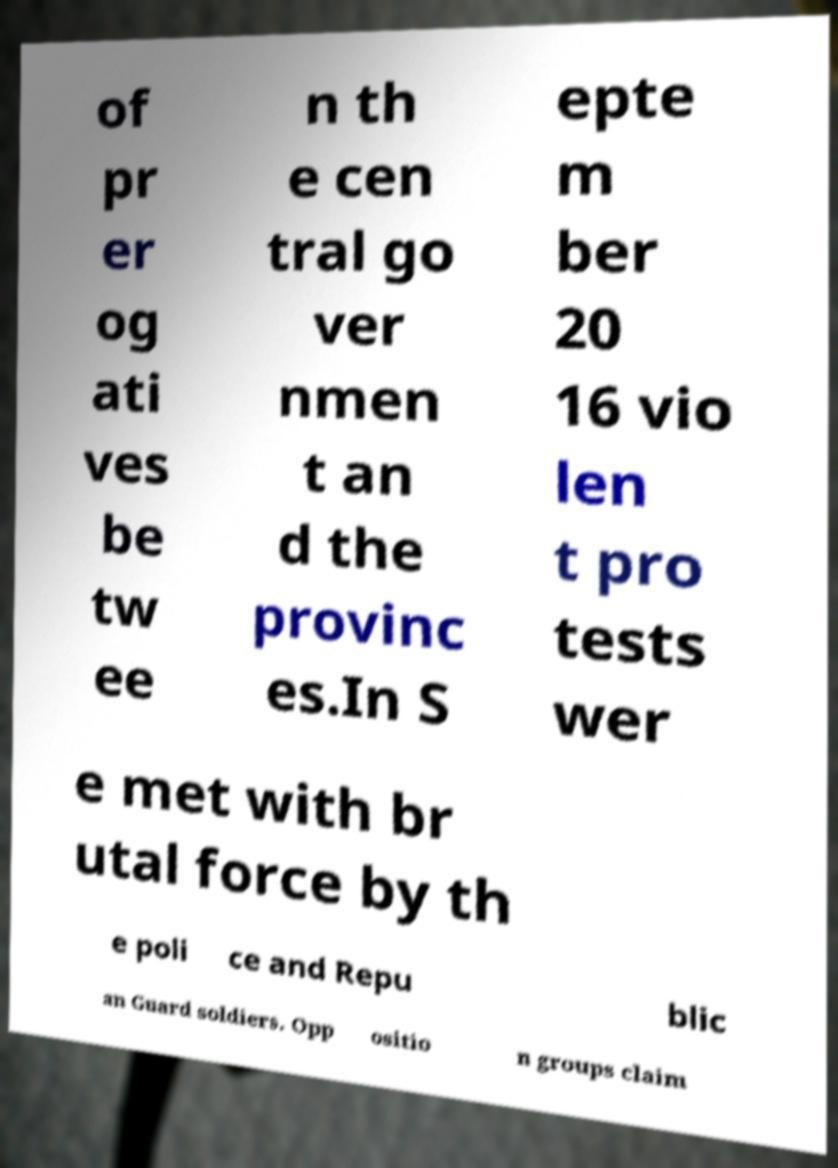Please identify and transcribe the text found in this image. of pr er og ati ves be tw ee n th e cen tral go ver nmen t an d the provinc es.In S epte m ber 20 16 vio len t pro tests wer e met with br utal force by th e poli ce and Repu blic an Guard soldiers. Opp ositio n groups claim 